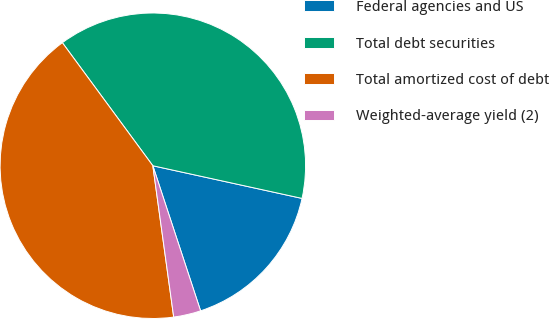Convert chart. <chart><loc_0><loc_0><loc_500><loc_500><pie_chart><fcel>Federal agencies and US<fcel>Total debt securities<fcel>Total amortized cost of debt<fcel>Weighted-average yield (2)<nl><fcel>16.51%<fcel>38.52%<fcel>42.09%<fcel>2.88%<nl></chart> 